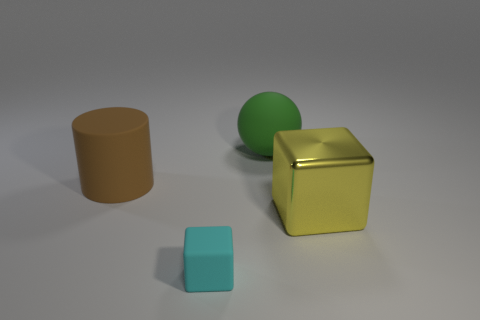Subtract all yellow cubes. How many cubes are left? 1 Add 2 tiny spheres. How many objects exist? 6 Subtract 0 red blocks. How many objects are left? 4 Subtract all balls. How many objects are left? 3 Subtract all red cubes. Subtract all brown cylinders. How many cubes are left? 2 Subtract all gray spheres. How many purple blocks are left? 0 Subtract all small cyan metal balls. Subtract all big metal objects. How many objects are left? 3 Add 3 cyan blocks. How many cyan blocks are left? 4 Add 3 green things. How many green things exist? 4 